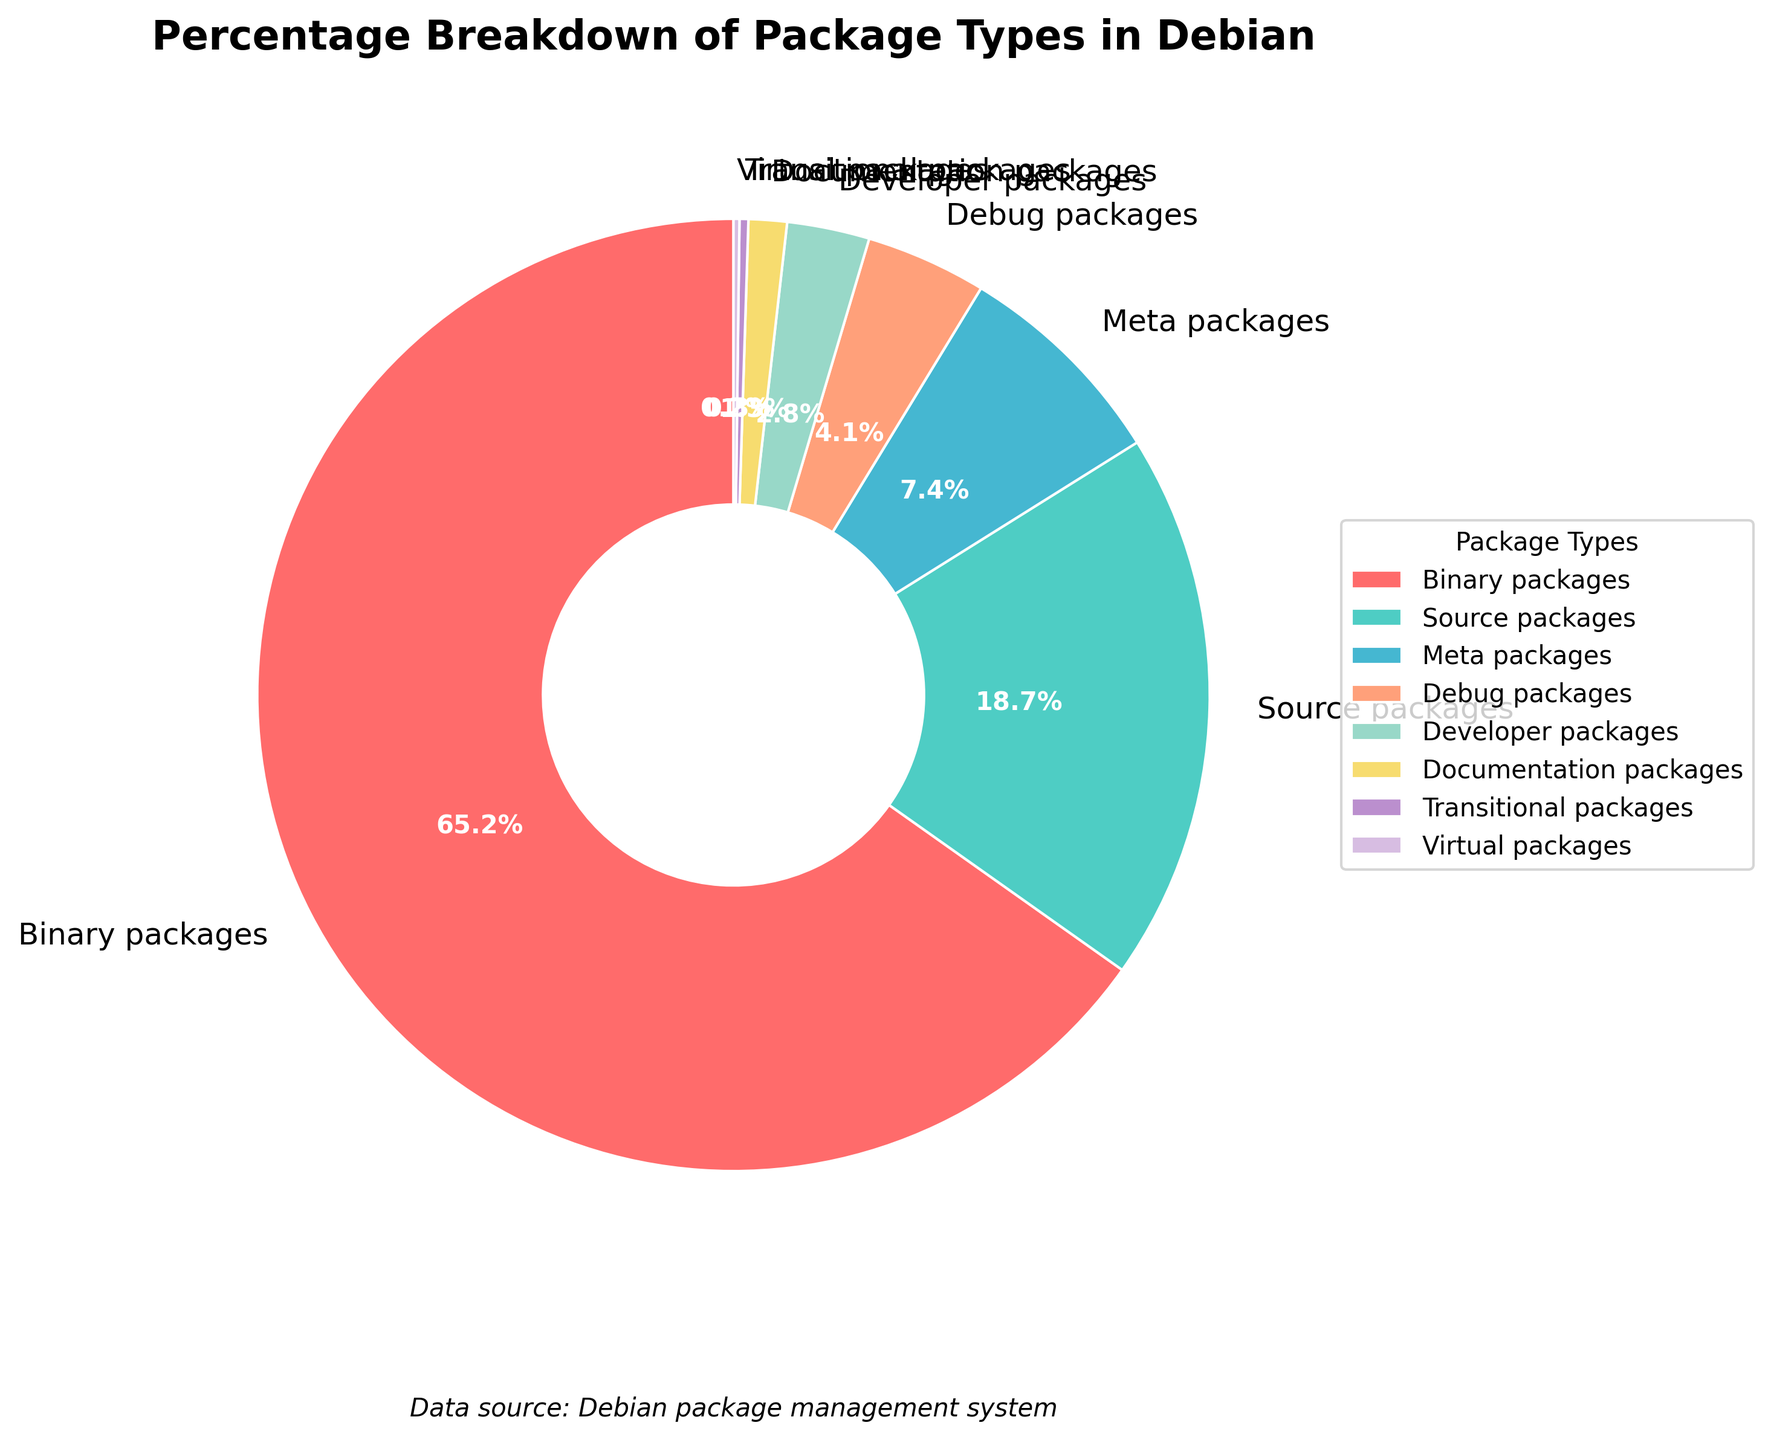What percentage of packages are Binary packages? The Binary packages section in the pie chart shows 65.2%, so Binary packages account for 65.2% of the total.
Answer: 65.2% What's the total percentage of Source and Meta packages combined? Source packages account for 18.7% and Meta packages for 7.4%. Adding these percentages together: 18.7 + 7.4 = 26.1%.
Answer: 26.1% Are Virtual packages more or less common than Transitional packages? Virtual packages represent 0.2% of the total, while Transitional packages are 0.3%. Since 0.2% is less than 0.3%, Virtual packages are less common than Transitional packages.
Answer: Virtual packages are less common Which package type has the smallest percentage, and what is it? The pie chart shows that Virtual packages have the smallest percentage at 0.2%.
Answer: Virtual packages with 0.2% How does the percentage of Developer packages compare to Debug packages? Developer packages account for 2.8%, and Debug packages account for 4.1%. Since 2.8% is less than 4.1%, Developer packages are less common than Debug packages.
Answer: Developer packages are less common What's the difference in percentage between the most common and least common package types? The most common package type, Binary packages, accounts for 65.2%, while the least common, Virtual packages, represents 0.2%. The difference is 65.2 - 0.2 = 65.0%.
Answer: 65.0% How many package types have a percentage greater than 5%? The pie chart shows three types over 5%: Binary packages (65.2%), Source packages (18.7%), and Meta packages (7.4%).
Answer: 3 What's the combined percentage of all package types with less than 5% each? Summing the percentages of Debug (4.1%), Developer (2.8%), Documentation (1.3%), Transitional (0.3%), and Virtual (0.2%) packages gives 4.1 + 2.8 + 1.3 + 0.3 + 0.2 = 8.7%.
Answer: 8.7% 